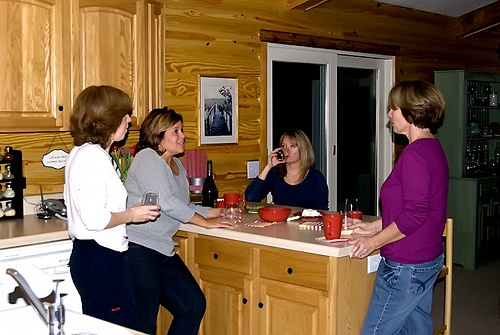Describe the objects in this image and their specific colors. I can see people in orange, purple, gray, black, and blue tones, people in orange, black, white, and maroon tones, people in orange, black, darkgray, brown, and maroon tones, people in orange, black, brown, and maroon tones, and bottle in orange, black, maroon, and gray tones in this image. 